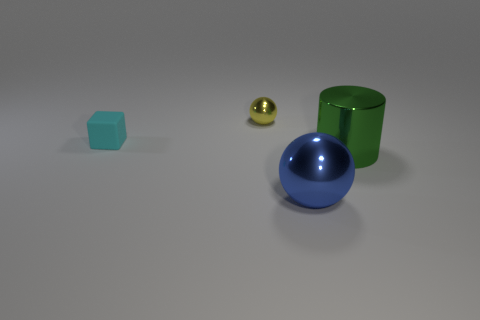There is a sphere behind the big cylinder; is its size the same as the metallic sphere in front of the large cylinder?
Ensure brevity in your answer.  No. What shape is the object that is left of the tiny thing that is right of the cyan rubber block?
Your answer should be compact. Cube. There is a green cylinder; is it the same size as the metal sphere in front of the cube?
Provide a succinct answer. Yes. There is a metal sphere to the left of the ball that is to the right of the shiny object that is behind the small rubber cube; how big is it?
Your answer should be very brief. Small. What number of things are either shiny balls on the left side of the blue metal thing or large purple cylinders?
Provide a succinct answer. 1. There is a object that is on the right side of the big blue shiny thing; what number of green things are on the right side of it?
Offer a very short reply. 0. Are there more small things right of the tiny rubber block than green blocks?
Your answer should be very brief. Yes. There is a thing that is both on the left side of the cylinder and in front of the small cyan block; how big is it?
Your response must be concise. Large. There is a thing that is on the left side of the big blue metal object and to the right of the tiny matte cube; what is its shape?
Ensure brevity in your answer.  Sphere. There is a shiny sphere that is to the left of the shiny ball in front of the rubber block; is there a tiny cyan rubber object in front of it?
Your response must be concise. Yes. 